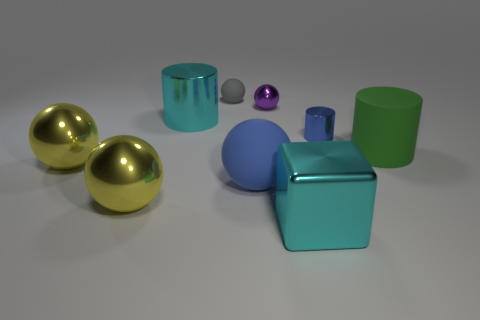Is the color of the large cube the same as the big metallic cylinder?
Ensure brevity in your answer.  Yes. Is there a object of the same color as the tiny metallic cylinder?
Keep it short and to the point. Yes. There is a matte thing that is the same size as the blue metal object; what is its color?
Offer a very short reply. Gray. Are there any big cyan shiny objects of the same shape as the blue shiny object?
Provide a succinct answer. Yes. There is a thing that is the same color as the tiny metal cylinder; what is its shape?
Ensure brevity in your answer.  Sphere. There is a large cylinder on the left side of the small gray object behind the big green matte cylinder; are there any tiny blue metal cylinders in front of it?
Your answer should be compact. Yes. There is a purple metal object that is the same size as the gray matte object; what shape is it?
Your answer should be compact. Sphere. There is a small metal object that is the same shape as the big green rubber object; what is its color?
Your answer should be very brief. Blue. What number of objects are either brown cubes or large green rubber things?
Offer a very short reply. 1. Do the large cyan object that is on the left side of the large blue rubber object and the big thing right of the tiny blue cylinder have the same shape?
Offer a terse response. Yes. 